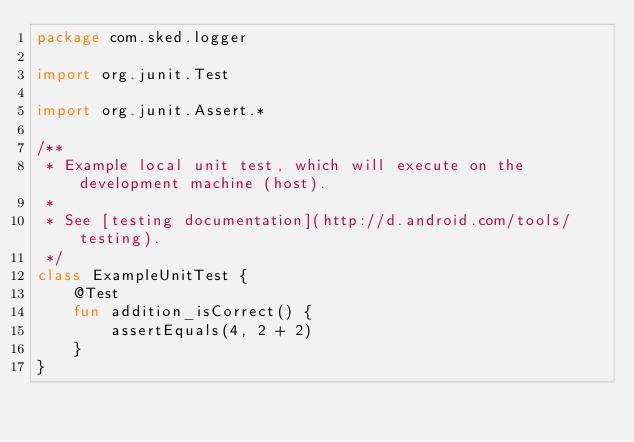<code> <loc_0><loc_0><loc_500><loc_500><_Kotlin_>package com.sked.logger

import org.junit.Test

import org.junit.Assert.*

/**
 * Example local unit test, which will execute on the development machine (host).
 *
 * See [testing documentation](http://d.android.com/tools/testing).
 */
class ExampleUnitTest {
    @Test
    fun addition_isCorrect() {
        assertEquals(4, 2 + 2)
    }
}
</code> 